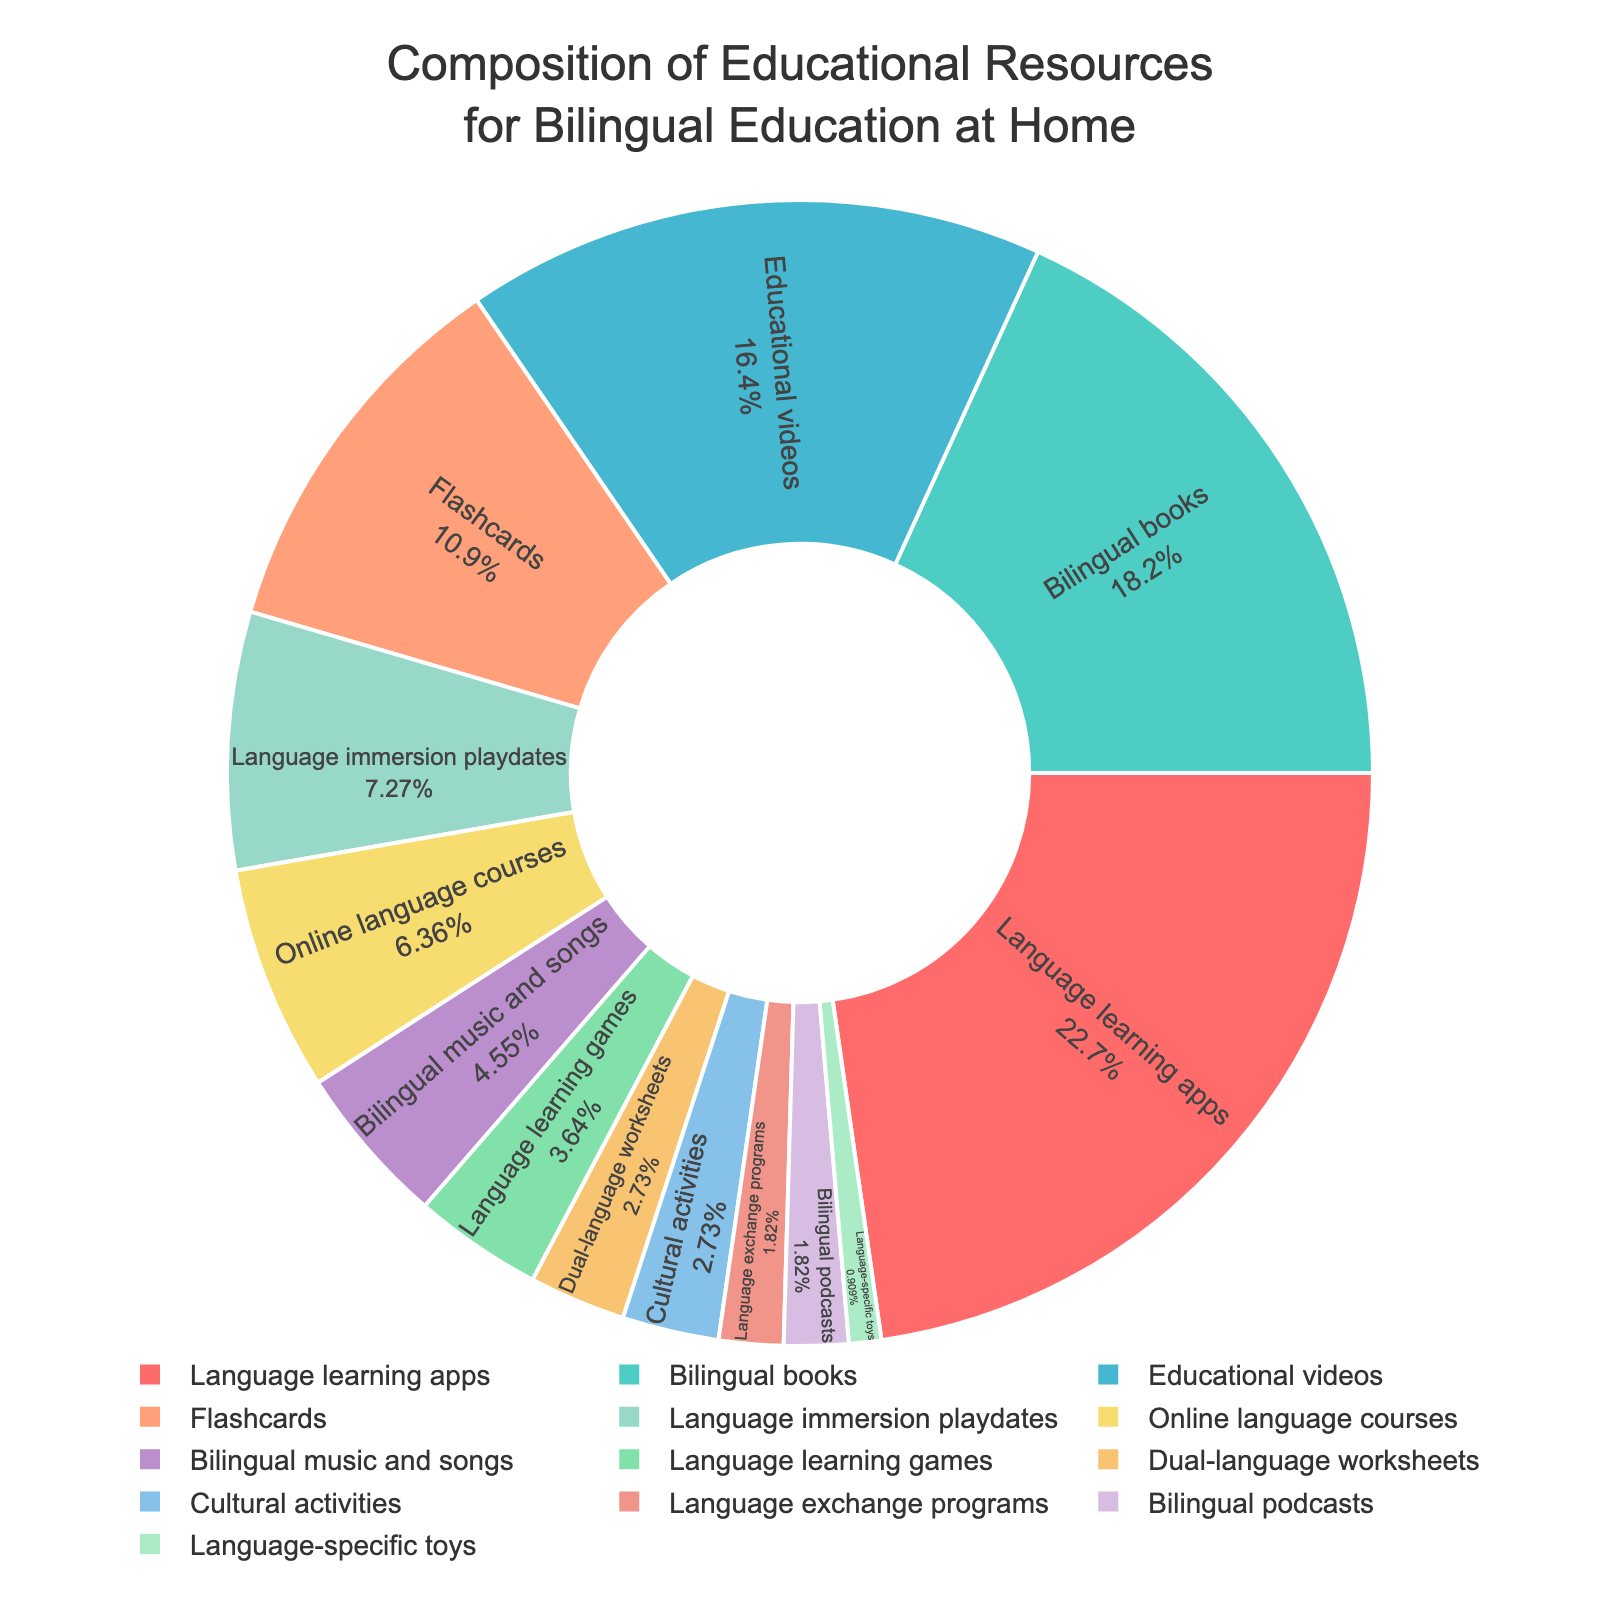Which category has the highest percentage of usage? To determine the category with the highest percentage, look for the largest segment in the pie chart.
Answer: Language learning apps What is the combined percentage of educational videos and flashcards? Locate the percentages for educational videos and flashcards in the pie chart. Add them up: 18% + 12%.
Answer: 30% How does the usage of bilingual books compare to language learning apps? Compare the percentages for bilingual books and language learning apps. Language learning apps are 25%, and bilingual books are 20%.
Answer: Language learning apps are used more Which category has the smallest percentage, and what is it? Identify the smallest segment in the pie chart. Language-specific toys has the smallest percentage at 1%.
Answer: Language-specific toys, 1% What is the difference in percentage between the usage of online language courses and language immersion playdates? Locate the percentages for online language courses and language immersion playdates. Subtract the smaller percentage from the larger one: 8% - 7%.
Answer: 1% Out of the categories listed, which one occupies the largest segment of renewable percentages below 10%? Identify segments below 10% and find the category with the highest value. Language immersion playdates have the highest percentage below 10%, at 8%.
Answer: Language immersion playdates What is the total percentage of the top three used educational resources? List the top three educational resources by percentage and sum them: Language learning apps (25%), bilingual books (20%), and educational videos (18%). Add these percentages: 25% + 20% + 18%.
Answer: 63% Does bilingual music and songs have a higher or lower percentage than flashcards? Compare the pie chart segments. Bilingual music and songs are 5%, while flashcards are 12%.
Answer: Lower How much more popular are bilingual books compared to language-specific toys? Subtract the percentage of language-specific toys from the percentage of bilingual books: 20% - 1%.
Answer: 19% Which category shares the same percentage of usage as bilingual podcasts? Check the pie chart for categories with the same percentage. Both bilingual podcasts and language exchange programs have 2%.
Answer: Language exchange programs 